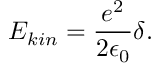<formula> <loc_0><loc_0><loc_500><loc_500>E _ { k i n } = \frac { e ^ { 2 } } { 2 \epsilon _ { 0 } } \delta .</formula> 